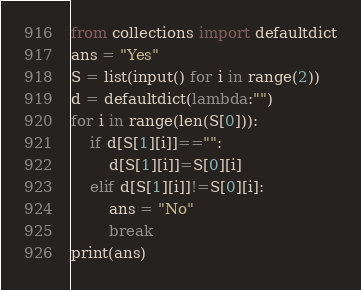Convert code to text. <code><loc_0><loc_0><loc_500><loc_500><_Python_>from collections import defaultdict
ans = "Yes"
S = list(input() for i in range(2))
d = defaultdict(lambda:"")
for i in range(len(S[0])):
    if d[S[1][i]]=="":
        d[S[1][i]]=S[0][i]
    elif d[S[1][i]]!=S[0][i]:
        ans = "No"
        break
print(ans)</code> 